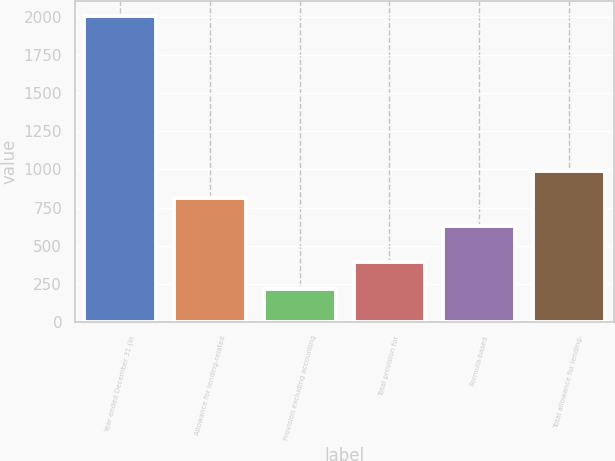Convert chart. <chart><loc_0><loc_0><loc_500><loc_500><bar_chart><fcel>Year ended December 31 (in<fcel>Allowance for lending-related<fcel>Provision excluding accounting<fcel>Total provision for<fcel>Formula-based<fcel>Total allowance for lending-<nl><fcel>2008<fcel>809.3<fcel>215<fcel>394.3<fcel>630<fcel>988.6<nl></chart> 